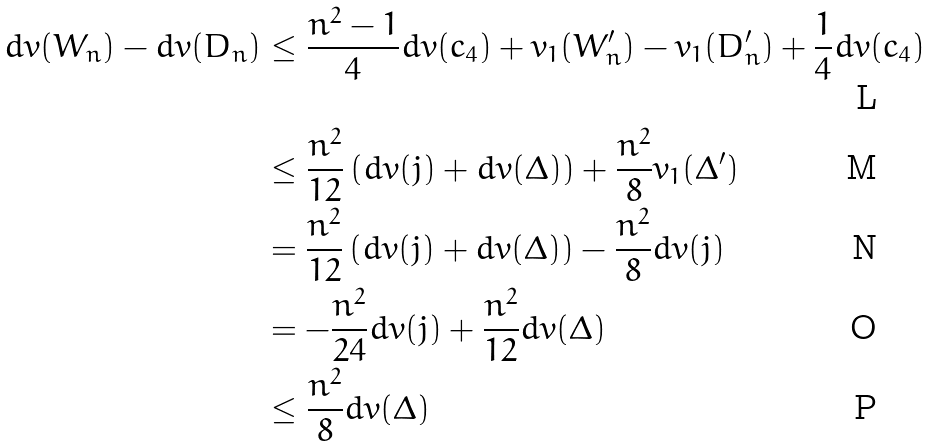<formula> <loc_0><loc_0><loc_500><loc_500>d v ( W _ { n } ) - d v ( D _ { n } ) & \leq \frac { n ^ { 2 } - 1 } { 4 } d v ( c _ { 4 } ) + v _ { 1 } ( W _ { n } ^ { \prime } ) - v _ { 1 } ( D _ { n } ^ { \prime } ) + \frac { 1 } { 4 } d v ( c _ { 4 } ) \\ & \leq \frac { n ^ { 2 } } { 1 2 } \left ( d v ( j ) + d v ( \Delta ) \right ) + \frac { n ^ { 2 } } { 8 } v _ { 1 } ( \Delta ^ { \prime } ) \\ & = \frac { n ^ { 2 } } { 1 2 } \left ( d v ( j ) + d v ( \Delta ) \right ) - \frac { n ^ { 2 } } { 8 } d v ( j ) \\ & = - \frac { n ^ { 2 } } { 2 4 } d v ( j ) + \frac { n ^ { 2 } } { 1 2 } d v ( \Delta ) \\ & \leq \frac { n ^ { 2 } } { 8 } d v ( \Delta )</formula> 